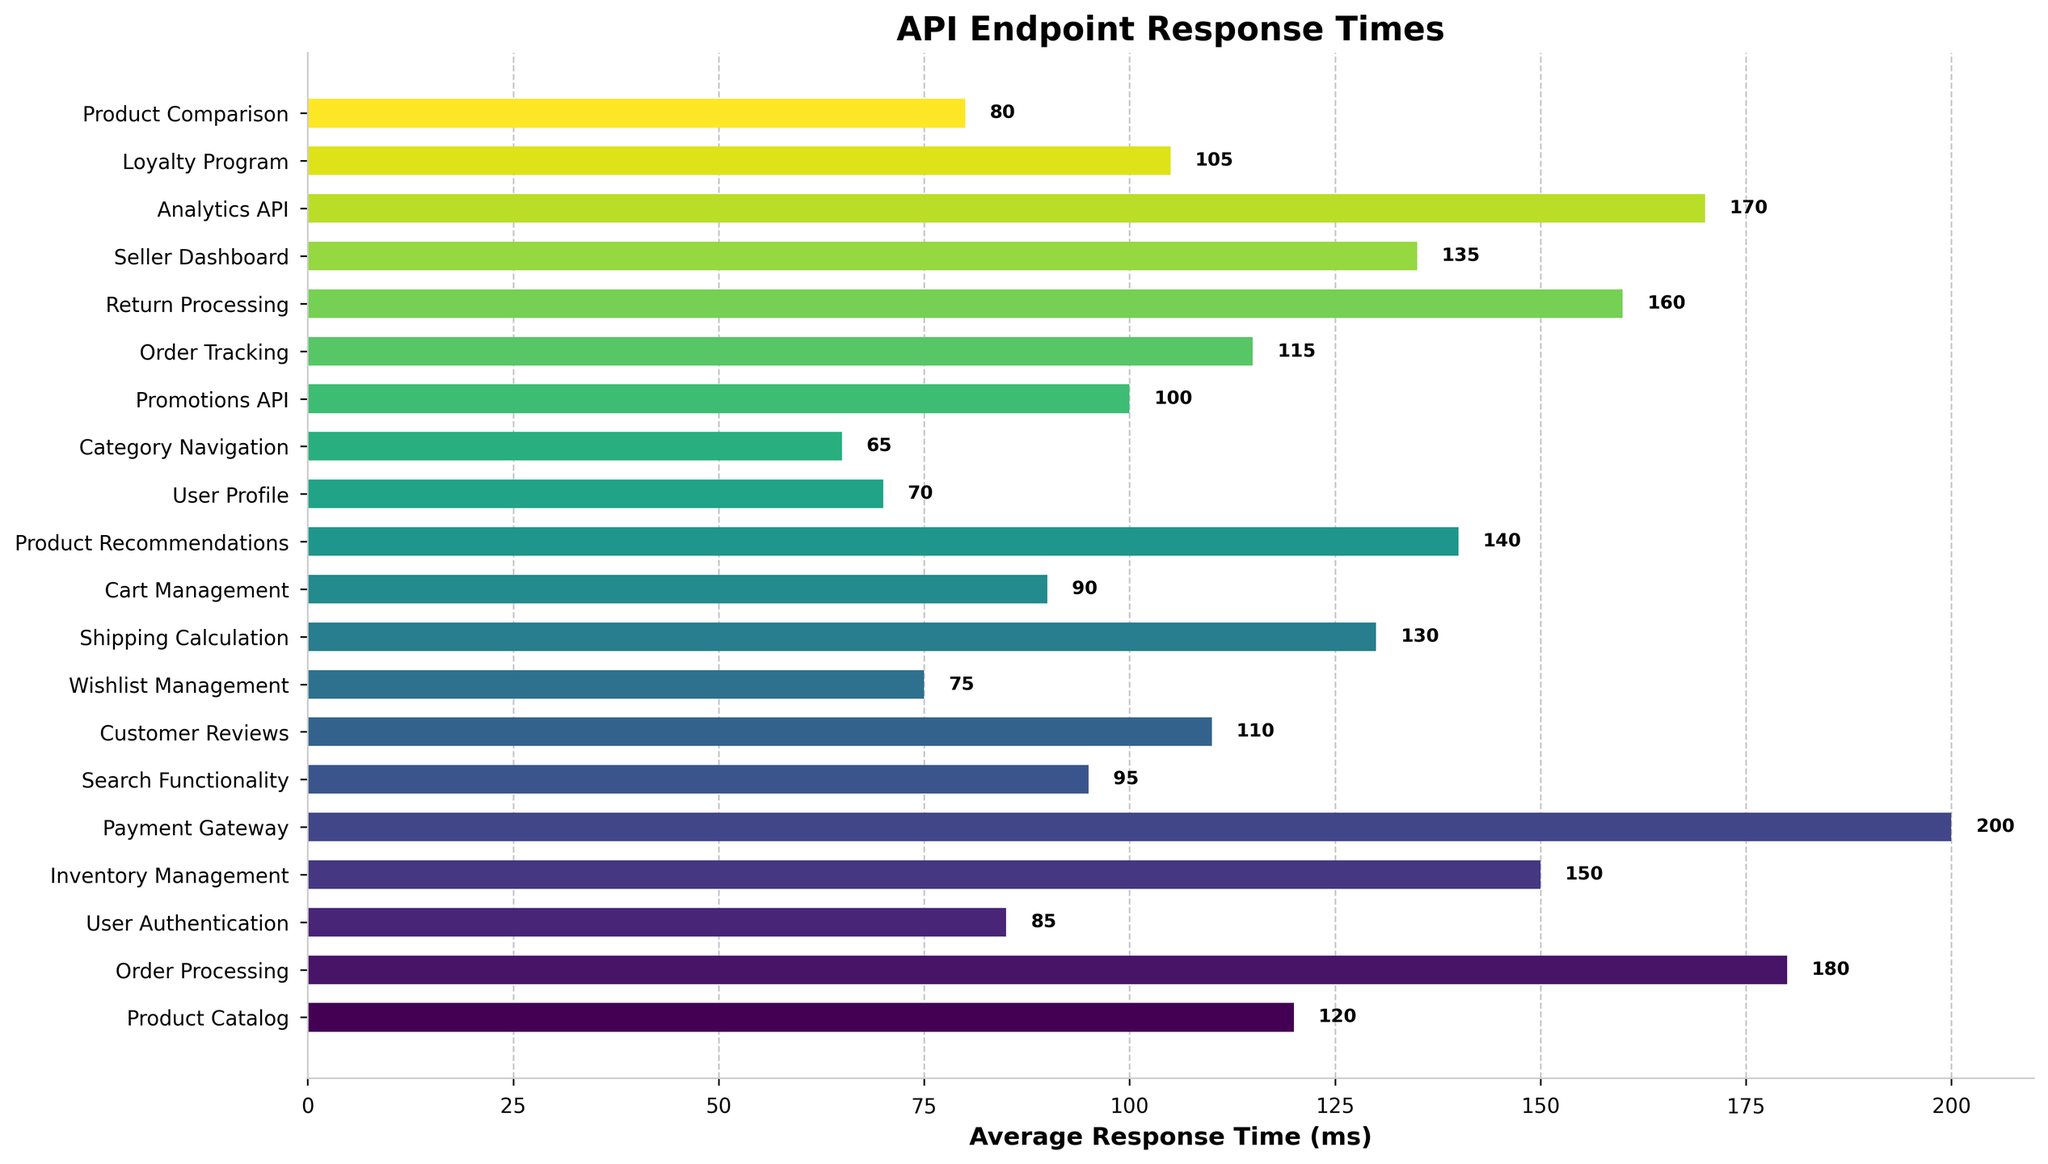Which endpoint has the highest average response time? By examining the bar lengths, the Payment Gateway endpoint has the longest bar, indicating the highest value.
Answer: Payment Gateway Which endpoint has the lowest average response time? By examining the bar lengths, the Category Navigation endpoint has the shortest bar, indicating the lowest value.
Answer: Category Navigation How much longer is the average response time of the Payment Gateway compared to User Authentication? The average response time of Payment Gateway is 200 ms and for User Authentication is 85 ms. The difference is calculated as 200 - 85 = 115 ms.
Answer: 115 ms What is the combined average response time for Product Catalog and Inventory Management endpoints? Sum the average response times of the two endpoints: Product Catalog (120 ms) + Inventory Management (150 ms) = 270 ms.
Answer: 270 ms Which endpoint has an average response time of exactly 115 ms? Identify the endpoint by locating the bar corresponding to the 115 ms value. The Order Tracking endpoint has this exact value.
Answer: Order Tracking What is the average response time for the endpoints that have a response time less than 100 ms? The endpoints are User Authentication (85 ms), Search Functionality (95 ms), Wishlist Management (75 ms), Cart Management (90 ms), User Profile (70 ms), Category Navigation (65 ms), Product Comparison (80 ms), Promotions API (100 ms). The sum is 85 + 95 + 75 + 90 + 70 + 65 + 80 = 560 and there are 7 endpoints. 560 / 7 = 80 ms.
Answer: 80 ms Which API endpoint has a response time closer to the average response time of Wishlist Management or Cart Management? Wishlist Management has 75 ms and Cart Management has 90 ms. The average of these two is (75 + 90) / 2 = 82.5 ms. The User Authentication endpoint with 85 ms is closer to 82.5 ms.
Answer: User Authentication What is the difference in average response time between the Seller Dashboard and Analytics API endpoints? Identify the average response times: Seller Dashboard (135 ms) and Analytics API (170 ms). The difference is 170 - 135 = 35 ms.
Answer: 35 ms How does the average response time of Return Processing compare to that of Inventory Management? Return Processing has an average response time of 160 ms and Inventory Management has 150 ms. 160 ms is 10 ms higher than 150 ms.
Answer: 10 ms higher If we group endpoints by average response times above and below 100 ms, how many endpoints fall into each category? There are 11 endpoints with response times above 100 ms (Product Catalog, Order Processing, Inventory Management, Payment Gateway, Shipping Calculation, Product Recommendations, Order Tracking, Return Processing, Seller Dashboard, Analytics API, Loyalty Program) and 9 endpoints below 100 ms (User Authentication, Search Functionality, Customer Reviews, Wishlist Management, Cart Management, User Profile, Category Navigation, Promotions API, Product Comparison).
Answer: 11 above, 9 below 